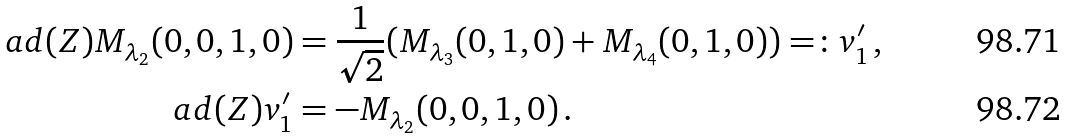<formula> <loc_0><loc_0><loc_500><loc_500>\ a d ( Z ) M _ { \lambda _ { 2 } } ( 0 , 0 , 1 , 0 ) & = \frac { 1 } { \sqrt { 2 } } ( M _ { \lambda _ { 3 } } ( 0 , 1 , 0 ) + M _ { \lambda _ { 4 } } ( 0 , 1 , 0 ) ) = \colon v _ { 1 } ^ { \prime } \, , \\ \ a d ( Z ) v _ { 1 } ^ { \prime } & = - M _ { \lambda _ { 2 } } ( 0 , 0 , 1 , 0 ) \, .</formula> 